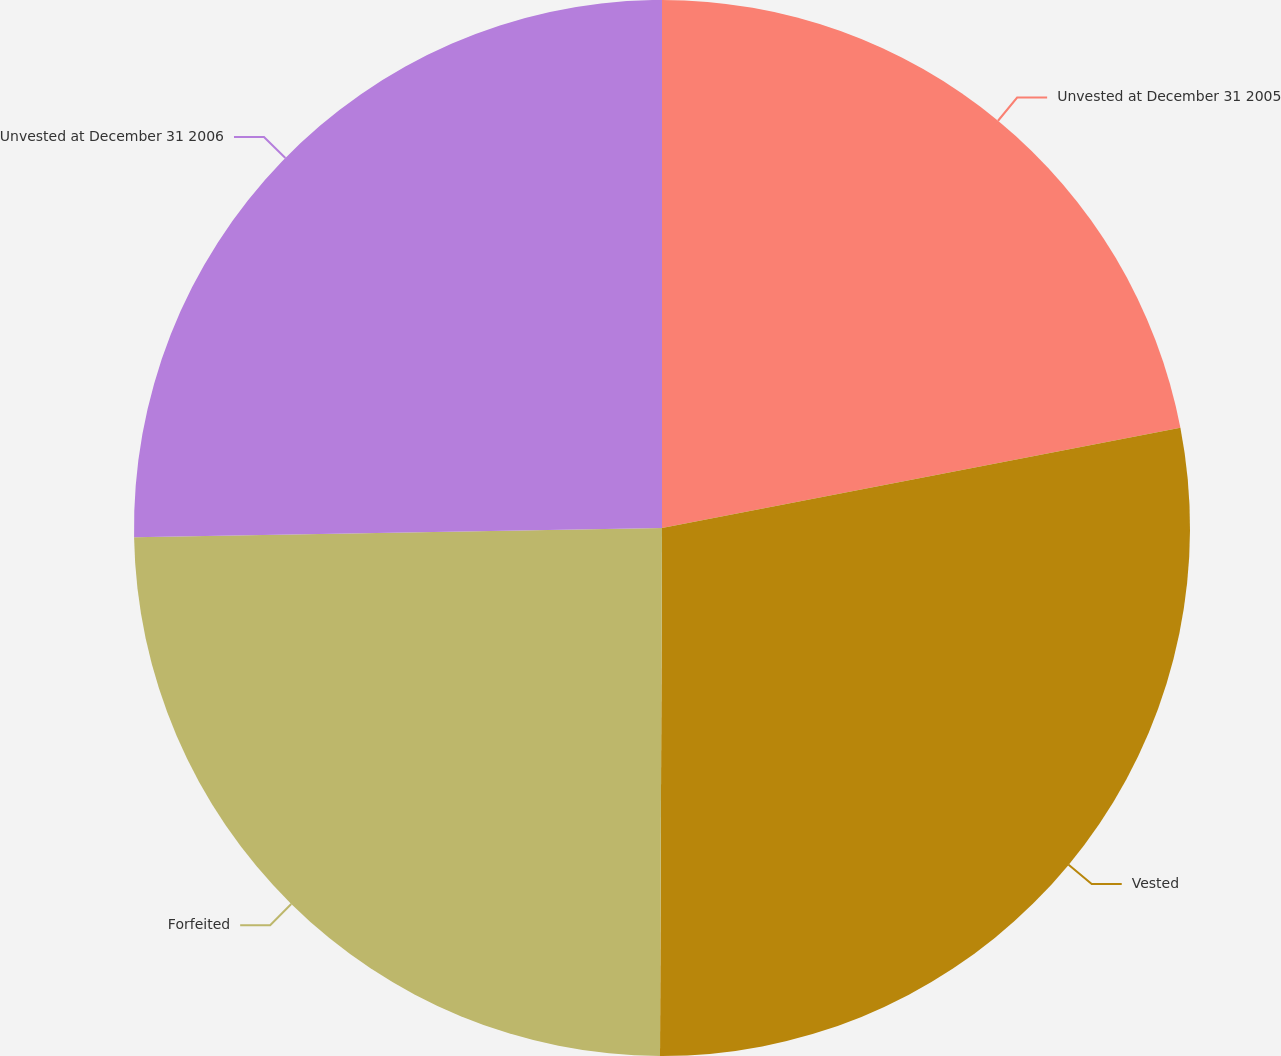<chart> <loc_0><loc_0><loc_500><loc_500><pie_chart><fcel>Unvested at December 31 2005<fcel>Vested<fcel>Forfeited<fcel>Unvested at December 31 2006<nl><fcel>21.96%<fcel>28.1%<fcel>24.66%<fcel>25.28%<nl></chart> 